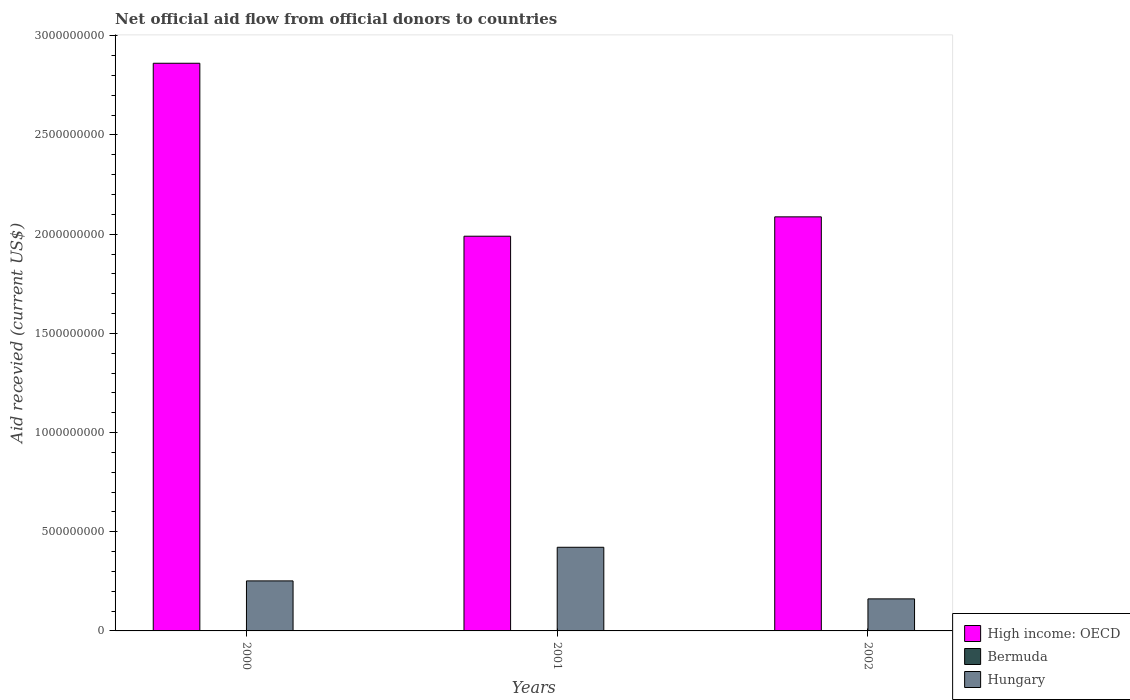How many different coloured bars are there?
Your response must be concise. 3. Are the number of bars per tick equal to the number of legend labels?
Give a very brief answer. Yes. Are the number of bars on each tick of the X-axis equal?
Ensure brevity in your answer.  Yes. How many bars are there on the 2nd tick from the right?
Make the answer very short. 3. In how many cases, is the number of bars for a given year not equal to the number of legend labels?
Your answer should be very brief. 0. What is the total aid received in High income: OECD in 2001?
Ensure brevity in your answer.  1.99e+09. Across all years, what is the maximum total aid received in Bermuda?
Provide a succinct answer. 6.00e+04. What is the total total aid received in Bermuda in the graph?
Provide a short and direct response. 1.00e+05. What is the difference between the total aid received in Hungary in 2000 and that in 2002?
Make the answer very short. 9.06e+07. What is the difference between the total aid received in Hungary in 2000 and the total aid received in Bermuda in 2001?
Provide a short and direct response. 2.52e+08. What is the average total aid received in High income: OECD per year?
Keep it short and to the point. 2.31e+09. In the year 2002, what is the difference between the total aid received in Hungary and total aid received in High income: OECD?
Provide a short and direct response. -1.93e+09. In how many years, is the total aid received in High income: OECD greater than 500000000 US$?
Your response must be concise. 3. What is the ratio of the total aid received in Hungary in 2000 to that in 2002?
Offer a terse response. 1.56. What is the difference between the highest and the second highest total aid received in High income: OECD?
Provide a succinct answer. 7.74e+08. What is the difference between the highest and the lowest total aid received in Hungary?
Give a very brief answer. 2.60e+08. What does the 3rd bar from the left in 2001 represents?
Keep it short and to the point. Hungary. What does the 2nd bar from the right in 2001 represents?
Make the answer very short. Bermuda. Is it the case that in every year, the sum of the total aid received in Bermuda and total aid received in Hungary is greater than the total aid received in High income: OECD?
Keep it short and to the point. No. Are all the bars in the graph horizontal?
Keep it short and to the point. No. How many years are there in the graph?
Provide a short and direct response. 3. Are the values on the major ticks of Y-axis written in scientific E-notation?
Keep it short and to the point. No. Does the graph contain any zero values?
Make the answer very short. No. What is the title of the graph?
Provide a succinct answer. Net official aid flow from official donors to countries. Does "Middle East & North Africa (developing only)" appear as one of the legend labels in the graph?
Your answer should be very brief. No. What is the label or title of the Y-axis?
Keep it short and to the point. Aid recevied (current US$). What is the Aid recevied (current US$) of High income: OECD in 2000?
Make the answer very short. 2.86e+09. What is the Aid recevied (current US$) of Hungary in 2000?
Keep it short and to the point. 2.52e+08. What is the Aid recevied (current US$) of High income: OECD in 2001?
Offer a very short reply. 1.99e+09. What is the Aid recevied (current US$) of Bermuda in 2001?
Provide a short and direct response. 2.00e+04. What is the Aid recevied (current US$) of Hungary in 2001?
Your answer should be compact. 4.22e+08. What is the Aid recevied (current US$) of High income: OECD in 2002?
Ensure brevity in your answer.  2.09e+09. What is the Aid recevied (current US$) in Bermuda in 2002?
Your answer should be very brief. 2.00e+04. What is the Aid recevied (current US$) in Hungary in 2002?
Your answer should be very brief. 1.62e+08. Across all years, what is the maximum Aid recevied (current US$) in High income: OECD?
Give a very brief answer. 2.86e+09. Across all years, what is the maximum Aid recevied (current US$) of Hungary?
Ensure brevity in your answer.  4.22e+08. Across all years, what is the minimum Aid recevied (current US$) in High income: OECD?
Provide a succinct answer. 1.99e+09. Across all years, what is the minimum Aid recevied (current US$) in Bermuda?
Provide a short and direct response. 2.00e+04. Across all years, what is the minimum Aid recevied (current US$) of Hungary?
Provide a short and direct response. 1.62e+08. What is the total Aid recevied (current US$) of High income: OECD in the graph?
Give a very brief answer. 6.94e+09. What is the total Aid recevied (current US$) in Hungary in the graph?
Offer a very short reply. 8.35e+08. What is the difference between the Aid recevied (current US$) of High income: OECD in 2000 and that in 2001?
Your answer should be compact. 8.72e+08. What is the difference between the Aid recevied (current US$) of Bermuda in 2000 and that in 2001?
Keep it short and to the point. 4.00e+04. What is the difference between the Aid recevied (current US$) of Hungary in 2000 and that in 2001?
Your answer should be very brief. -1.70e+08. What is the difference between the Aid recevied (current US$) in High income: OECD in 2000 and that in 2002?
Offer a terse response. 7.74e+08. What is the difference between the Aid recevied (current US$) of Bermuda in 2000 and that in 2002?
Provide a succinct answer. 4.00e+04. What is the difference between the Aid recevied (current US$) of Hungary in 2000 and that in 2002?
Ensure brevity in your answer.  9.06e+07. What is the difference between the Aid recevied (current US$) of High income: OECD in 2001 and that in 2002?
Ensure brevity in your answer.  -9.76e+07. What is the difference between the Aid recevied (current US$) of Bermuda in 2001 and that in 2002?
Provide a short and direct response. 0. What is the difference between the Aid recevied (current US$) in Hungary in 2001 and that in 2002?
Keep it short and to the point. 2.60e+08. What is the difference between the Aid recevied (current US$) in High income: OECD in 2000 and the Aid recevied (current US$) in Bermuda in 2001?
Your response must be concise. 2.86e+09. What is the difference between the Aid recevied (current US$) of High income: OECD in 2000 and the Aid recevied (current US$) of Hungary in 2001?
Provide a short and direct response. 2.44e+09. What is the difference between the Aid recevied (current US$) of Bermuda in 2000 and the Aid recevied (current US$) of Hungary in 2001?
Keep it short and to the point. -4.22e+08. What is the difference between the Aid recevied (current US$) of High income: OECD in 2000 and the Aid recevied (current US$) of Bermuda in 2002?
Offer a terse response. 2.86e+09. What is the difference between the Aid recevied (current US$) of High income: OECD in 2000 and the Aid recevied (current US$) of Hungary in 2002?
Provide a short and direct response. 2.70e+09. What is the difference between the Aid recevied (current US$) of Bermuda in 2000 and the Aid recevied (current US$) of Hungary in 2002?
Keep it short and to the point. -1.61e+08. What is the difference between the Aid recevied (current US$) of High income: OECD in 2001 and the Aid recevied (current US$) of Bermuda in 2002?
Make the answer very short. 1.99e+09. What is the difference between the Aid recevied (current US$) in High income: OECD in 2001 and the Aid recevied (current US$) in Hungary in 2002?
Provide a short and direct response. 1.83e+09. What is the difference between the Aid recevied (current US$) of Bermuda in 2001 and the Aid recevied (current US$) of Hungary in 2002?
Your answer should be very brief. -1.62e+08. What is the average Aid recevied (current US$) of High income: OECD per year?
Provide a short and direct response. 2.31e+09. What is the average Aid recevied (current US$) in Bermuda per year?
Ensure brevity in your answer.  3.33e+04. What is the average Aid recevied (current US$) in Hungary per year?
Ensure brevity in your answer.  2.78e+08. In the year 2000, what is the difference between the Aid recevied (current US$) of High income: OECD and Aid recevied (current US$) of Bermuda?
Give a very brief answer. 2.86e+09. In the year 2000, what is the difference between the Aid recevied (current US$) in High income: OECD and Aid recevied (current US$) in Hungary?
Make the answer very short. 2.61e+09. In the year 2000, what is the difference between the Aid recevied (current US$) in Bermuda and Aid recevied (current US$) in Hungary?
Give a very brief answer. -2.52e+08. In the year 2001, what is the difference between the Aid recevied (current US$) in High income: OECD and Aid recevied (current US$) in Bermuda?
Your answer should be very brief. 1.99e+09. In the year 2001, what is the difference between the Aid recevied (current US$) in High income: OECD and Aid recevied (current US$) in Hungary?
Ensure brevity in your answer.  1.57e+09. In the year 2001, what is the difference between the Aid recevied (current US$) of Bermuda and Aid recevied (current US$) of Hungary?
Your answer should be very brief. -4.22e+08. In the year 2002, what is the difference between the Aid recevied (current US$) in High income: OECD and Aid recevied (current US$) in Bermuda?
Offer a very short reply. 2.09e+09. In the year 2002, what is the difference between the Aid recevied (current US$) in High income: OECD and Aid recevied (current US$) in Hungary?
Your answer should be compact. 1.93e+09. In the year 2002, what is the difference between the Aid recevied (current US$) in Bermuda and Aid recevied (current US$) in Hungary?
Your response must be concise. -1.62e+08. What is the ratio of the Aid recevied (current US$) of High income: OECD in 2000 to that in 2001?
Your answer should be compact. 1.44. What is the ratio of the Aid recevied (current US$) of Bermuda in 2000 to that in 2001?
Provide a short and direct response. 3. What is the ratio of the Aid recevied (current US$) in Hungary in 2000 to that in 2001?
Ensure brevity in your answer.  0.6. What is the ratio of the Aid recevied (current US$) in High income: OECD in 2000 to that in 2002?
Make the answer very short. 1.37. What is the ratio of the Aid recevied (current US$) in Hungary in 2000 to that in 2002?
Make the answer very short. 1.56. What is the ratio of the Aid recevied (current US$) of High income: OECD in 2001 to that in 2002?
Provide a succinct answer. 0.95. What is the ratio of the Aid recevied (current US$) of Hungary in 2001 to that in 2002?
Your answer should be compact. 2.61. What is the difference between the highest and the second highest Aid recevied (current US$) of High income: OECD?
Ensure brevity in your answer.  7.74e+08. What is the difference between the highest and the second highest Aid recevied (current US$) in Bermuda?
Keep it short and to the point. 4.00e+04. What is the difference between the highest and the second highest Aid recevied (current US$) in Hungary?
Give a very brief answer. 1.70e+08. What is the difference between the highest and the lowest Aid recevied (current US$) in High income: OECD?
Ensure brevity in your answer.  8.72e+08. What is the difference between the highest and the lowest Aid recevied (current US$) of Bermuda?
Offer a very short reply. 4.00e+04. What is the difference between the highest and the lowest Aid recevied (current US$) of Hungary?
Ensure brevity in your answer.  2.60e+08. 